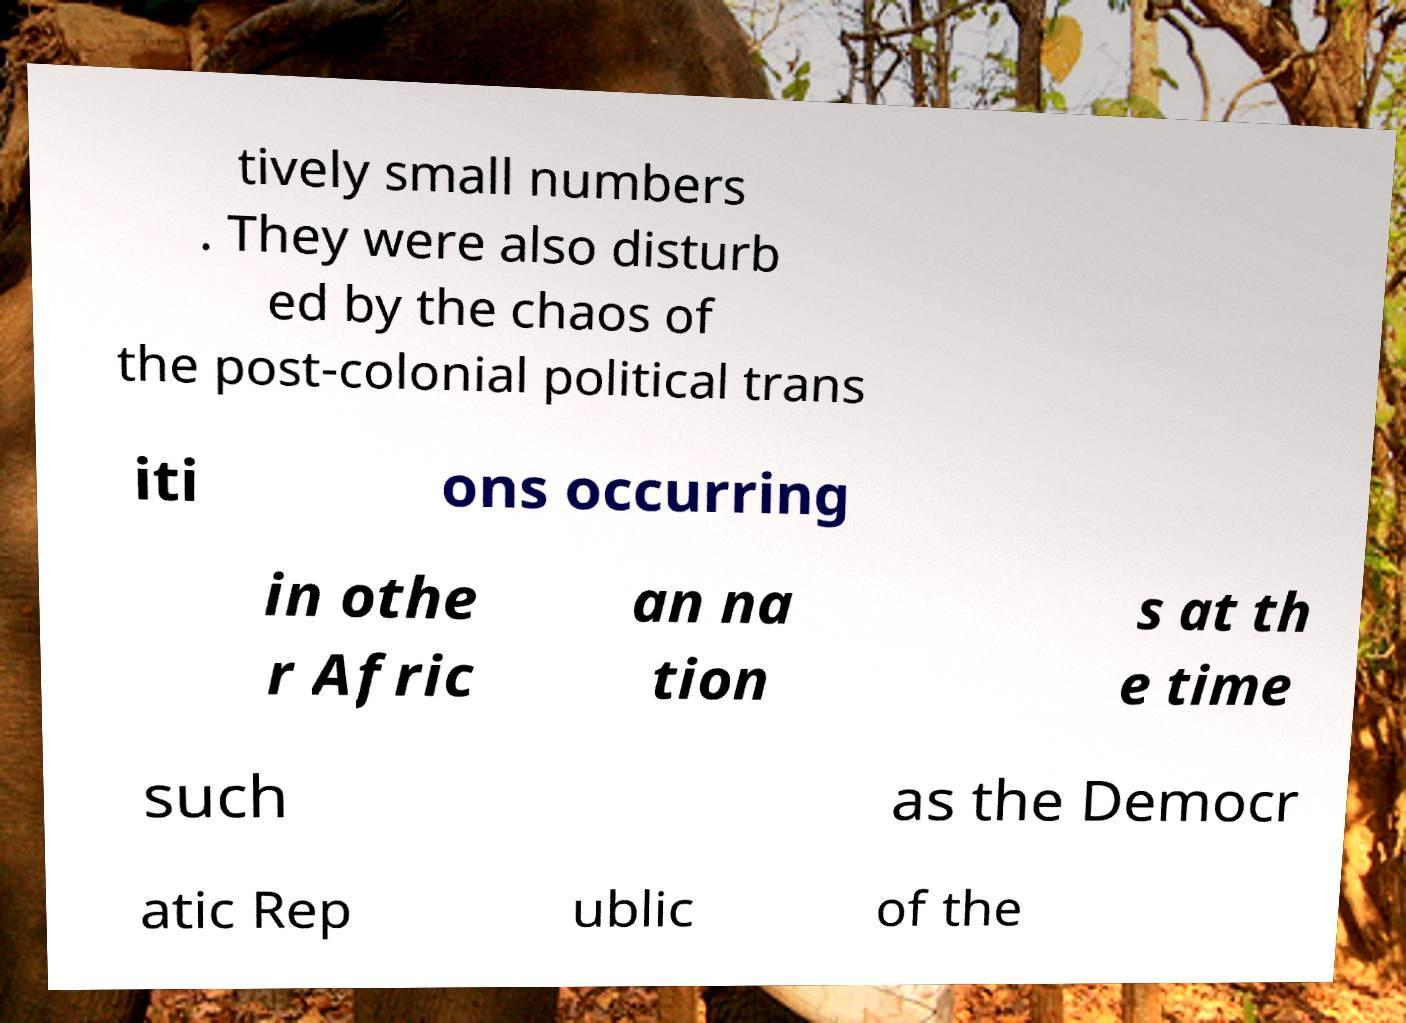Please read and relay the text visible in this image. What does it say? tively small numbers . They were also disturb ed by the chaos of the post-colonial political trans iti ons occurring in othe r Afric an na tion s at th e time such as the Democr atic Rep ublic of the 